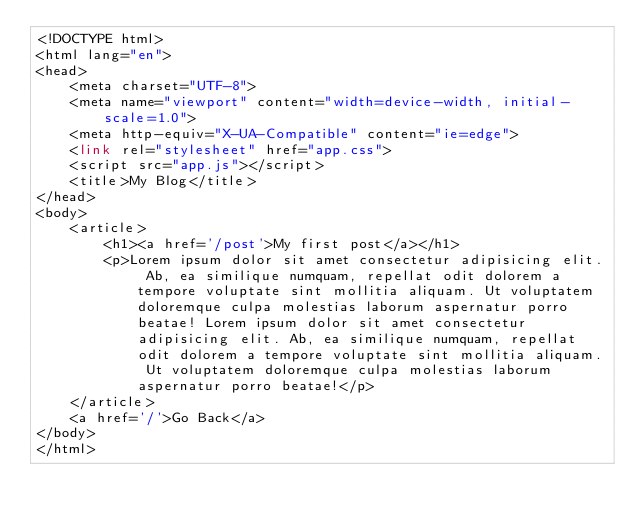<code> <loc_0><loc_0><loc_500><loc_500><_PHP_><!DOCTYPE html>
<html lang="en">
<head>
    <meta charset="UTF-8">
    <meta name="viewport" content="width=device-width, initial-scale=1.0">
    <meta http-equiv="X-UA-Compatible" content="ie=edge">
    <link rel="stylesheet" href="app.css">
    <script src="app.js"></script>
    <title>My Blog</title>
</head>
<body>
    <article>
        <h1><a href='/post'>My first post</a></h1>
        <p>Lorem ipsum dolor sit amet consectetur adipisicing elit. Ab, ea similique numquam, repellat odit dolorem a tempore voluptate sint mollitia aliquam. Ut voluptatem doloremque culpa molestias laborum aspernatur porro beatae! Lorem ipsum dolor sit amet consectetur adipisicing elit. Ab, ea similique numquam, repellat odit dolorem a tempore voluptate sint mollitia aliquam. Ut voluptatem doloremque culpa molestias laborum aspernatur porro beatae!</p>
    </article>
    <a href='/'>Go Back</a>
</body>
</html></code> 